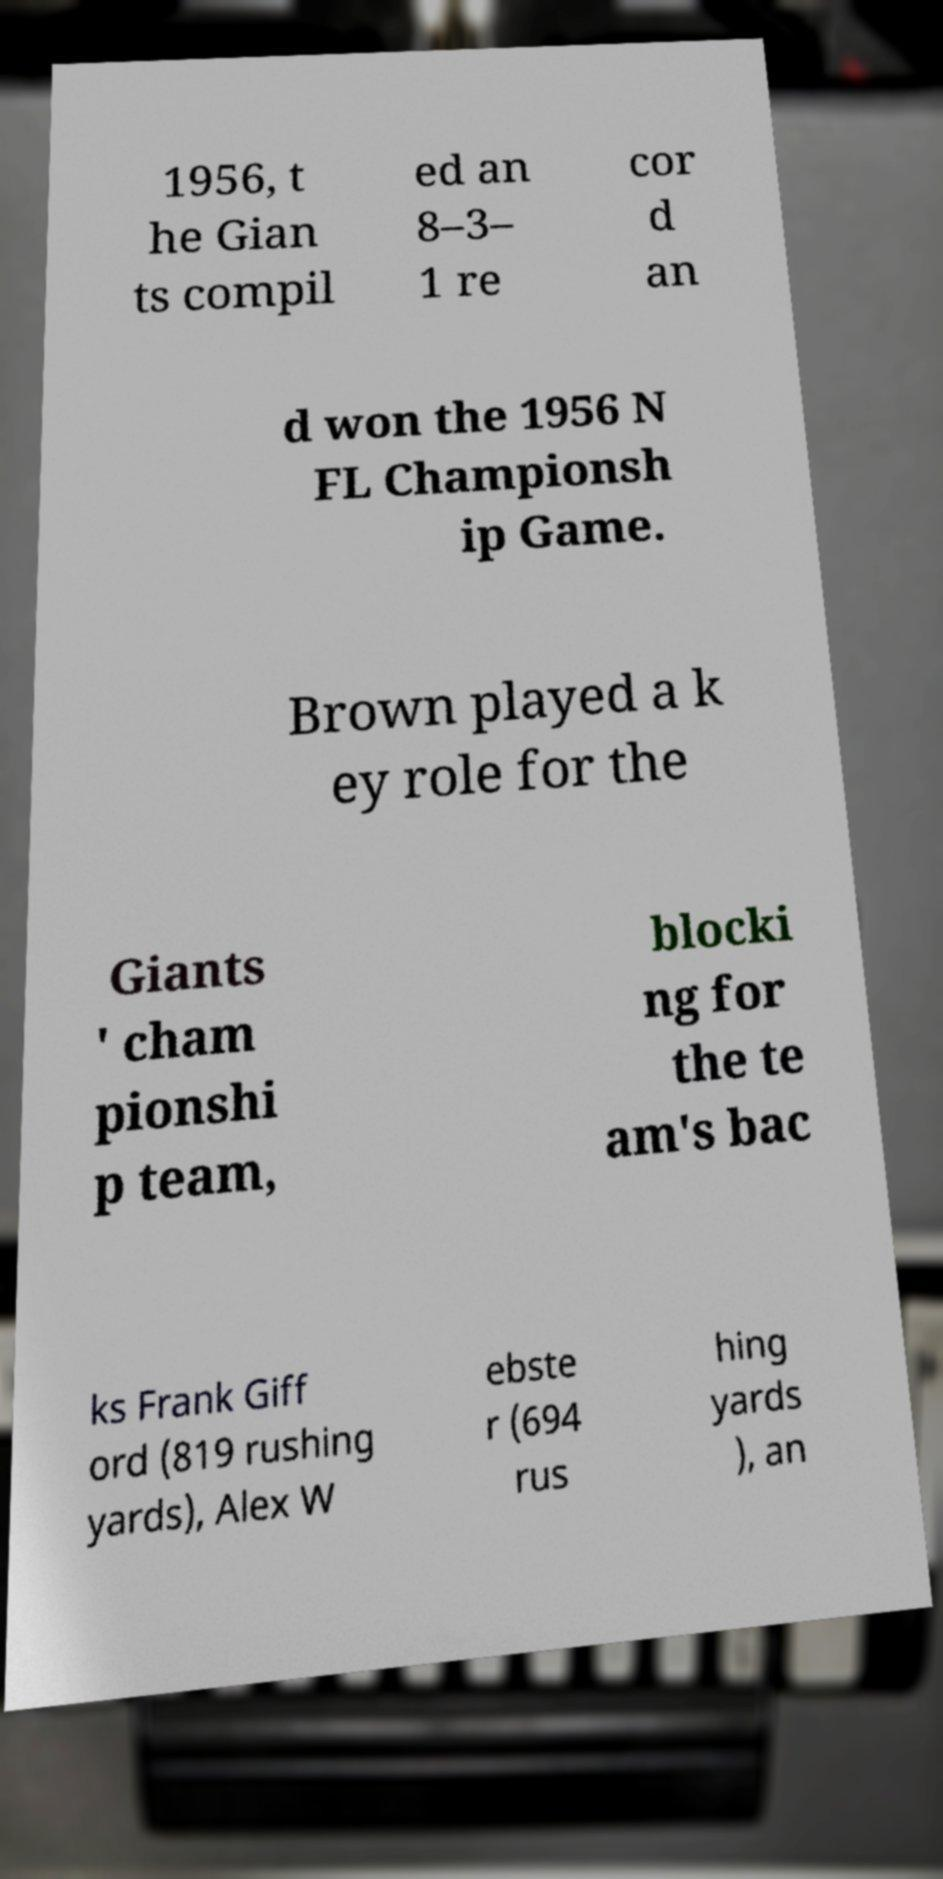Please read and relay the text visible in this image. What does it say? 1956, t he Gian ts compil ed an 8–3– 1 re cor d an d won the 1956 N FL Championsh ip Game. Brown played a k ey role for the Giants ' cham pionshi p team, blocki ng for the te am's bac ks Frank Giff ord (819 rushing yards), Alex W ebste r (694 rus hing yards ), an 